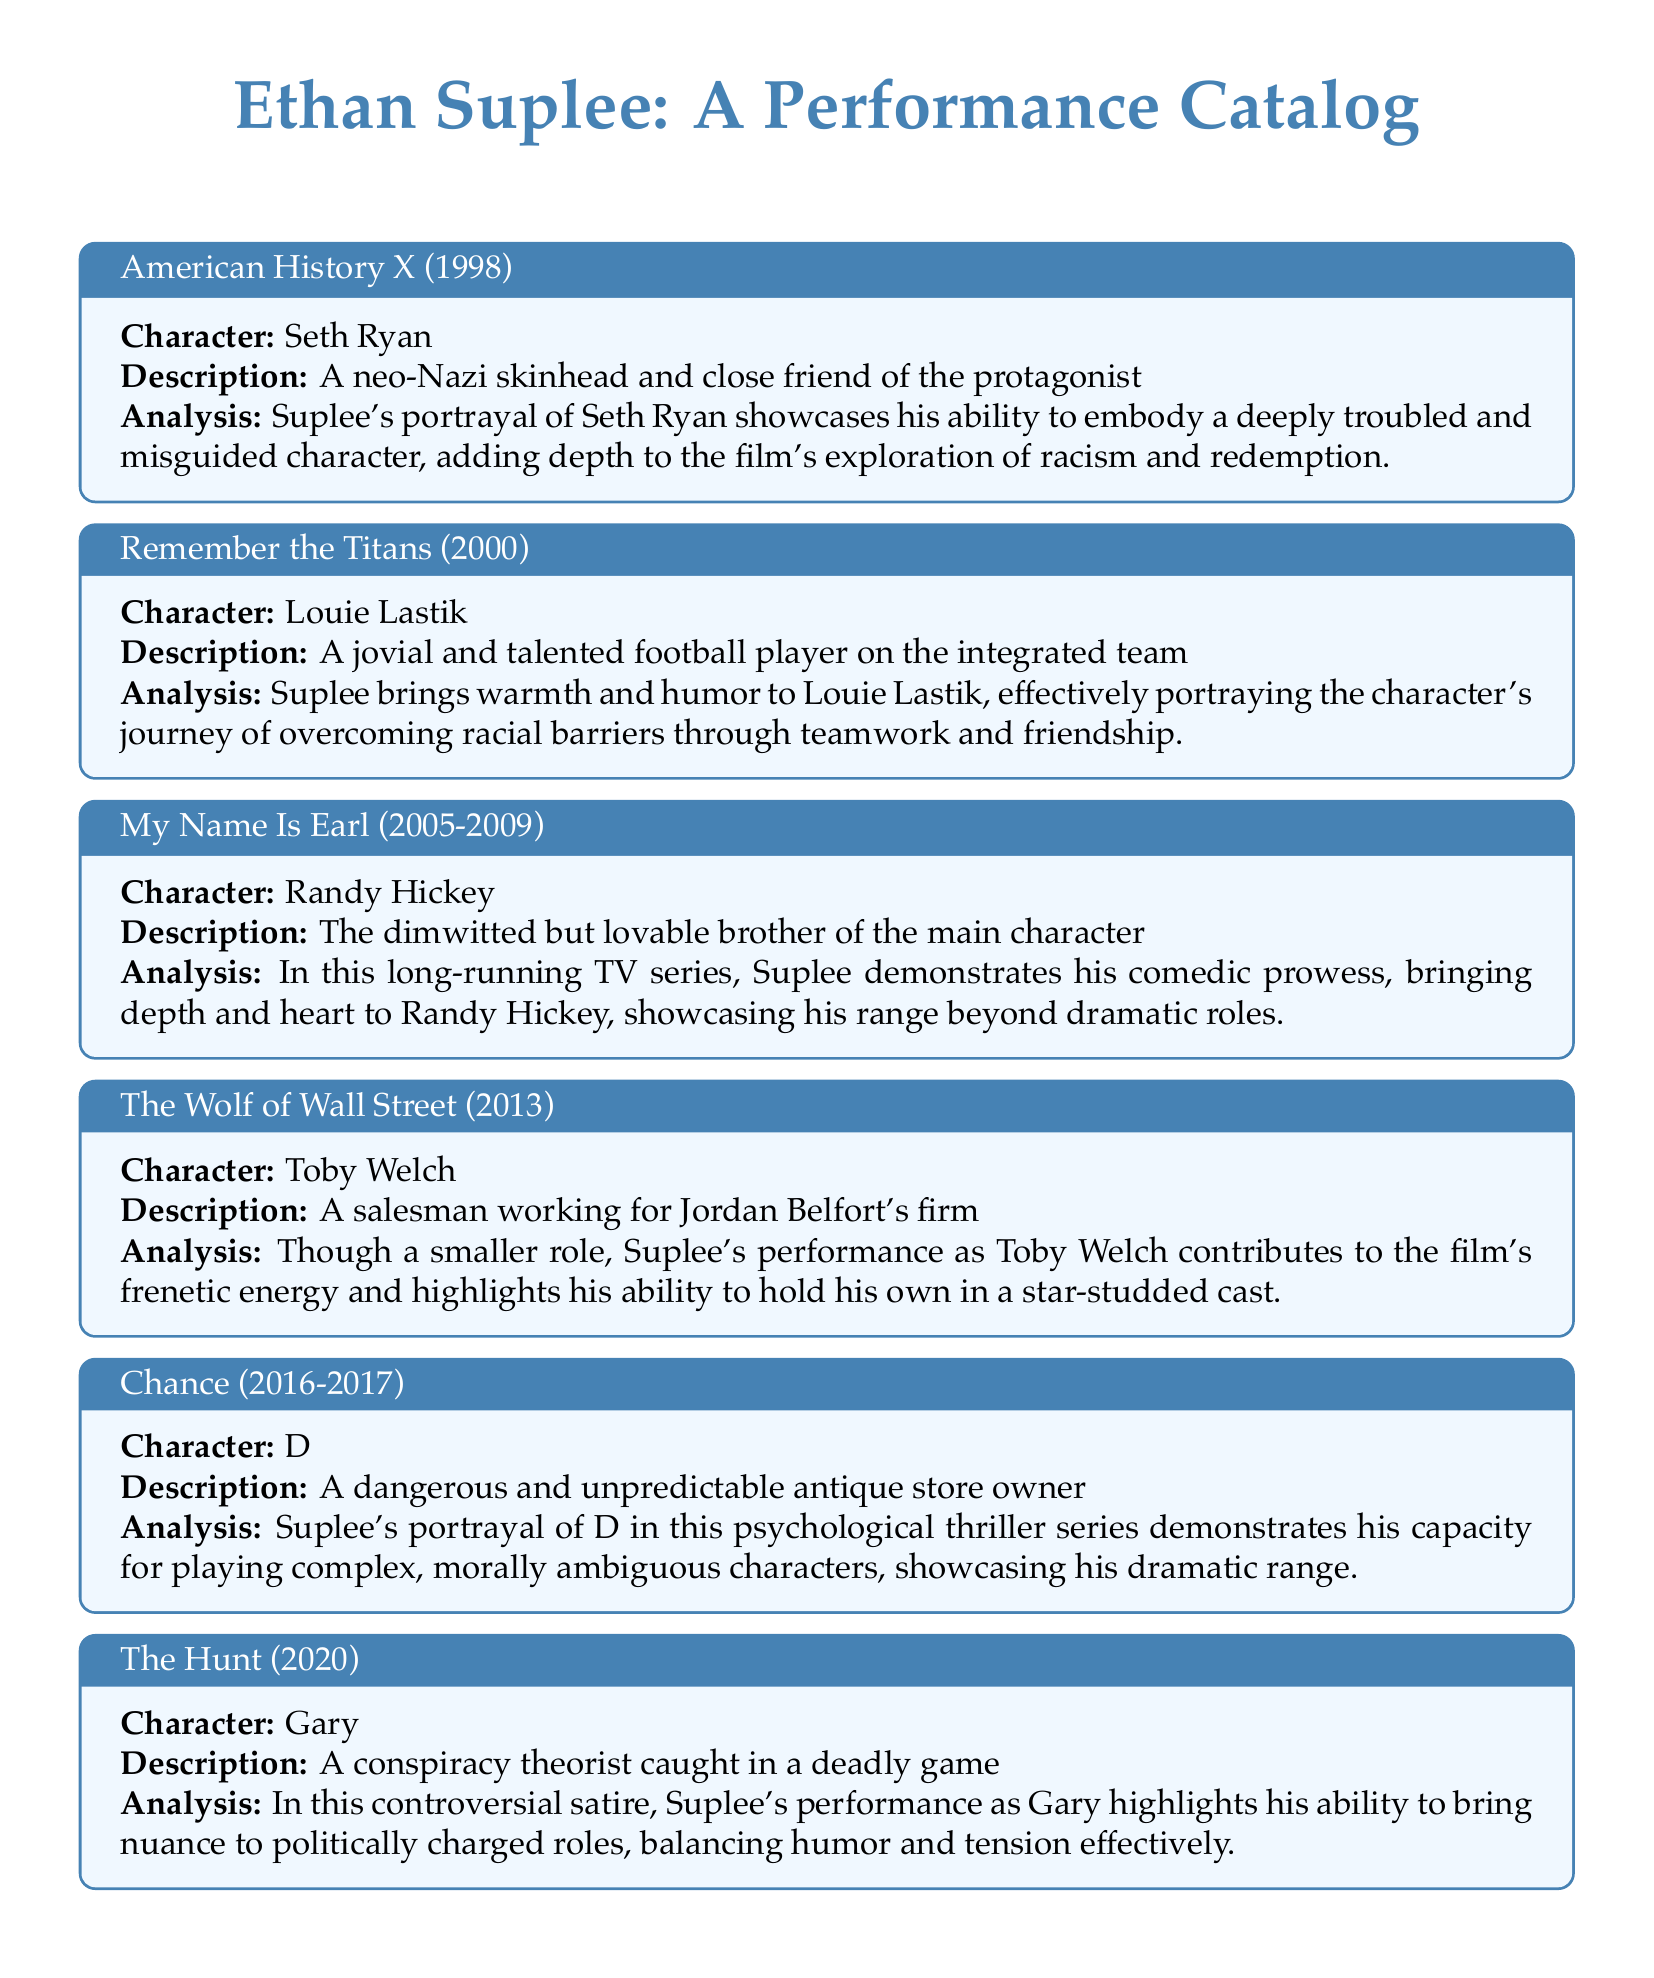What character did Ethan Suplee play in American History X? The catalog lists "Seth Ryan" as the character that Suplee portrayed in American History X.
Answer: Seth Ryan In which year was Remember the Titans released? The document indicates that Remember the Titans was released in the year 2000.
Answer: 2000 What is the main theme explored in American History X? The analysis section for American History X highlights "racism and redemption" as key themes.
Answer: Racism and redemption How does Suplee's performance in My Name Is Earl differ from his role in Chance? By examining the performances, Suplee portrays a comedic character in My Name Is Earl and a dangerous character in Chance, showcasing different aspects of his range.
Answer: Comedy vs. danger Which character is described as a "conspiracy theorist" in The Hunt? The document identifies the character played by Suplee in The Hunt as "Gary."
Answer: Gary What is one of the qualities of Suplee's role in The Wolf of Wall Street? The analysis mentions that Suplee's performance contributes to the film's "frenetic energy."
Answer: Frenetic energy How long did My Name Is Earl run? The document states that the series aired from 2005 to 2009, which totals four years.
Answer: Four years What type of character does Suplee portray in Chance? The description of D in the document indicates he is a "dangerous and unpredictable antique store owner."
Answer: Dangerous and unpredictable What does Ethan Suplee's performance in The Hunt highlight? The analysis notes that his performance brings "nuance to politically charged roles."
Answer: Nuance to politically charged roles 